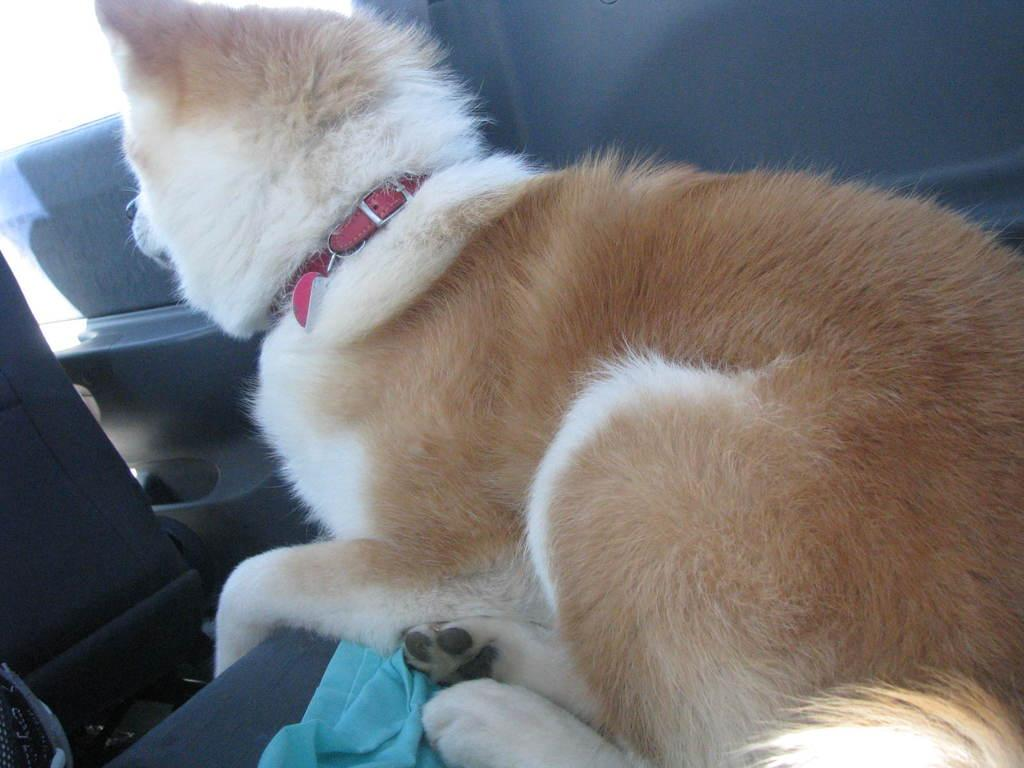What type of animal is sitting in the image? The specific type of animal cannot be determined from the provided facts. What is the cloth used for in the image? The purpose of the cloth cannot be determined from the provided facts. What can be inferred about the setting of the image? The image appears to depict the interior of a vehicle. How does the mother interact with the animal in the image? There is no mention of a mother in the provided facts, so it cannot be determined how she might interact with the animal. Is the coal used to fuel the vehicle in the image? There is no mention of coal in the provided facts, so it cannot be determined if it is used to fuel the vehicle. What is the weather like during the rainstorm in the image? There is no mention of a rainstorm in the provided facts, so it cannot be determined what the weather is like in the image. 